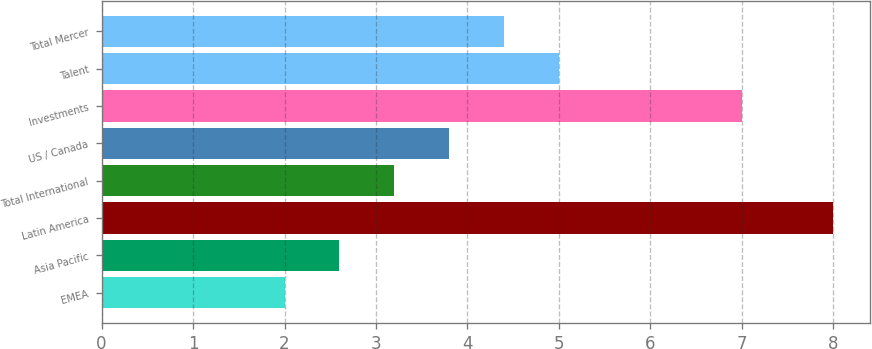Convert chart to OTSL. <chart><loc_0><loc_0><loc_500><loc_500><bar_chart><fcel>EMEA<fcel>Asia Pacific<fcel>Latin America<fcel>Total International<fcel>US / Canada<fcel>Investments<fcel>Talent<fcel>Total Mercer<nl><fcel>2<fcel>2.6<fcel>8<fcel>3.2<fcel>3.8<fcel>7<fcel>5<fcel>4.4<nl></chart> 